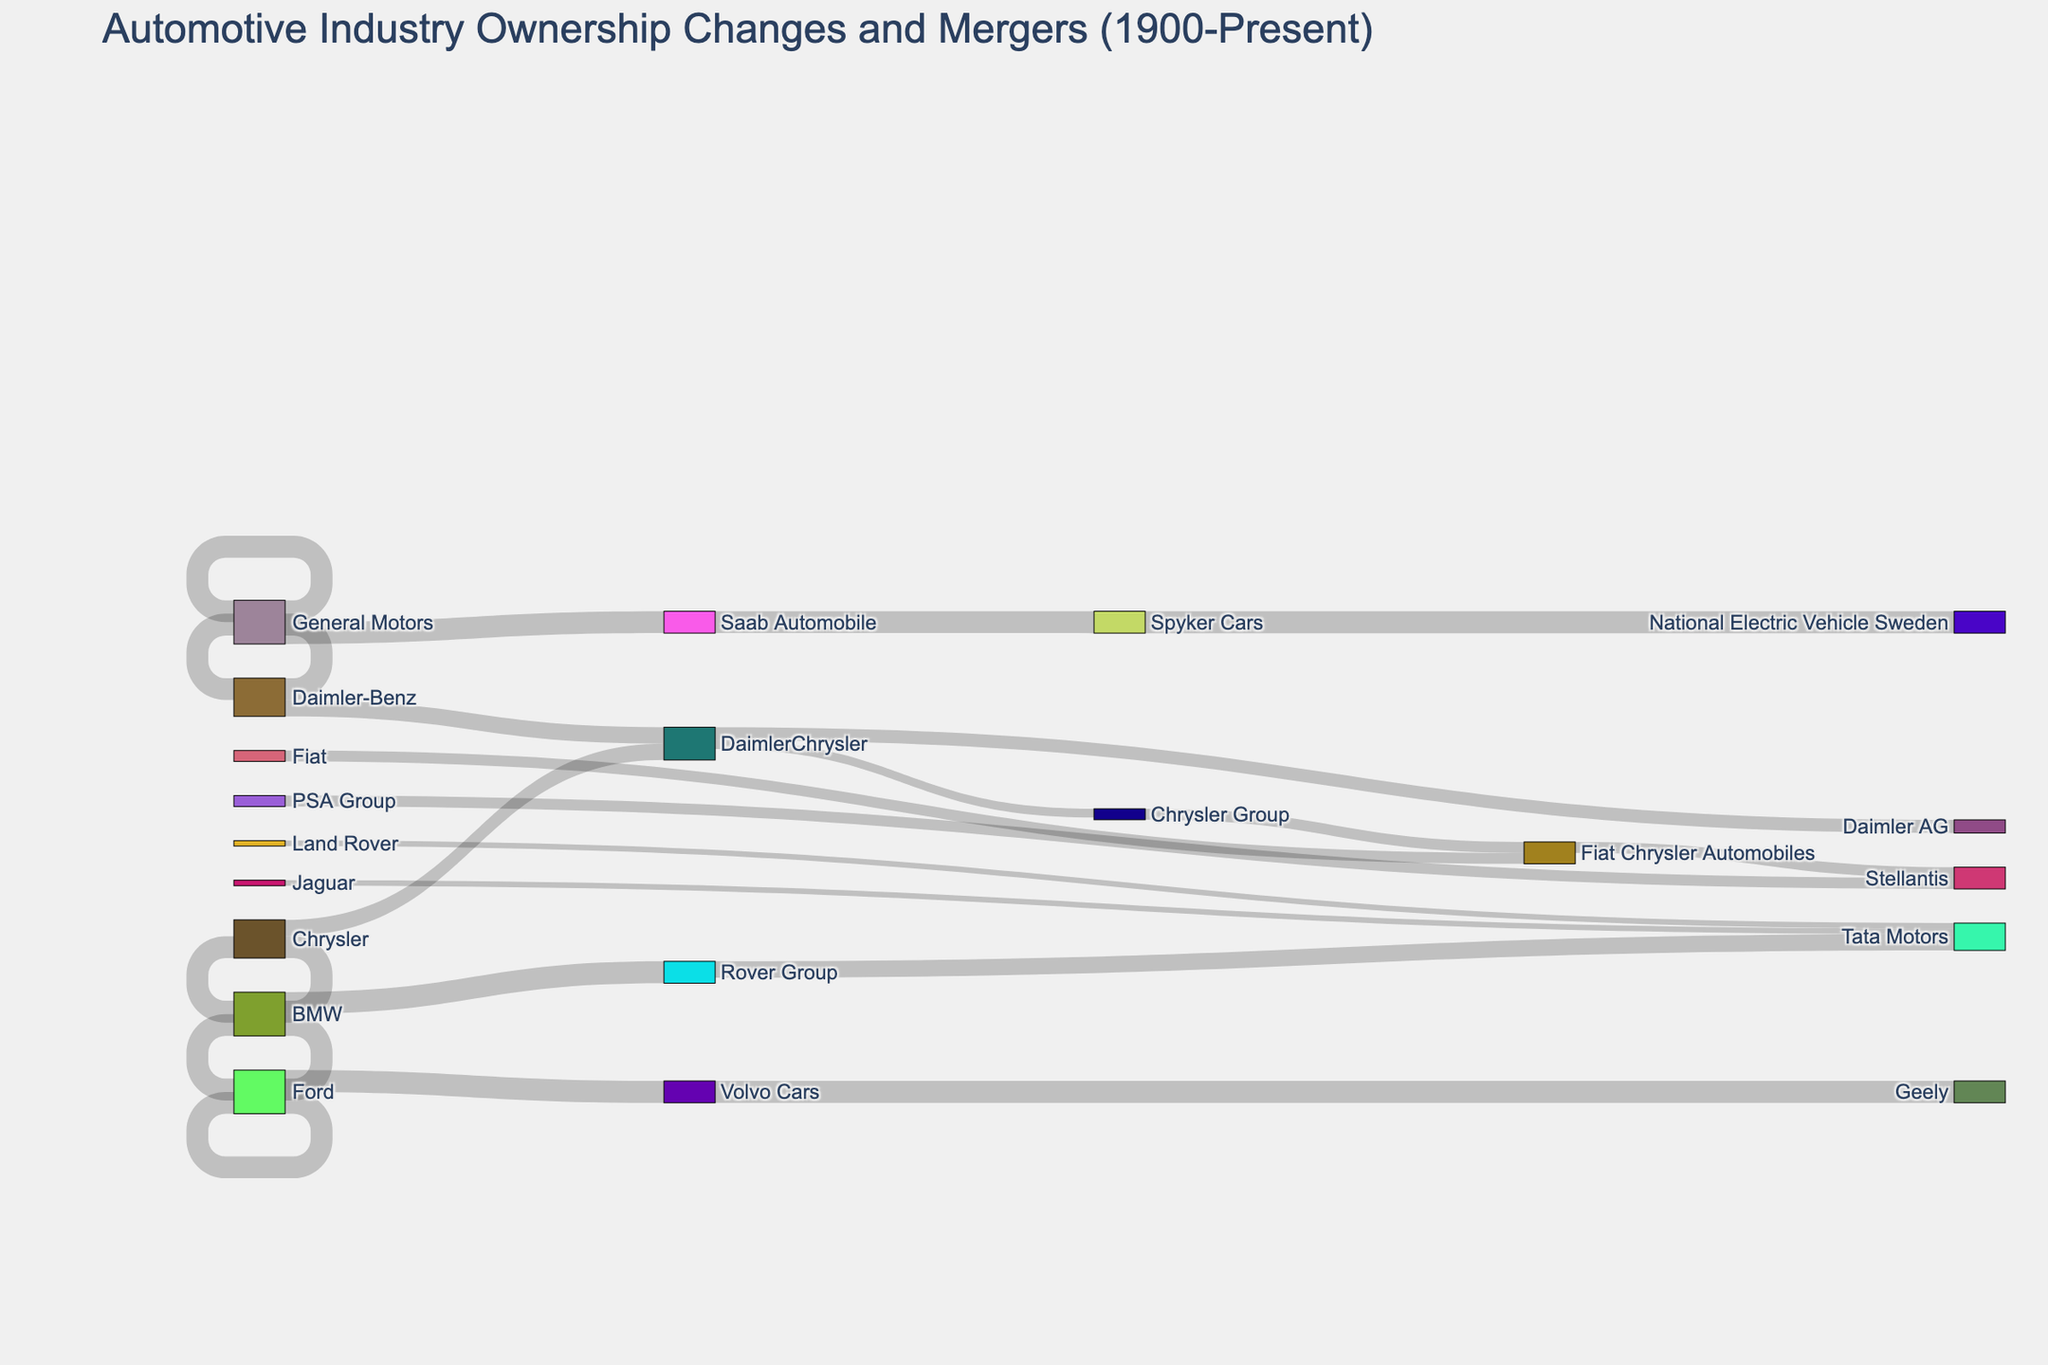How many companies does "Ford" directly transition to in the diagram? By examining the arrows originating from the "Ford" node, we see one arrow pointing towards "Volvo Cars." Consequently, Ford directly transitions to one other company.
Answer: One Which companies are involved in the merger that leads to the formation of DaimlerChrysler? The arrows in the diagram indicate a merger between "Chrysler" and "Daimler-Benz" to form "DaimlerChrysler." Both companies are sources of arrows converging into the "DaimlerChrysler" target node.
Answer: Chrysler and Daimler-Benz What happens to "Volvo Cars" according to the diagram? The diagram shows one arrow originating from "Volvo Cars" and leading to "Geely." This transition represents the ownership change of Volvo Cars to Geely.
Answer: Purchased by Geely What are the end states of "Fiat Chrysler Automobiles" in the diagram? According to the arrows, "Fiat Chrysler Automobiles" transitions to "Stellantis." Hence, the end state of Fiat Chrysler Automobiles leads to Stellantis.
Answer: Stellantis Which company transitions to Tata Motors besides the Rover Group? The diagram shows two arrows pointing towards Tata Motors, originating from "Rover Group" and "Jaguar." These indicate that both of these entities transitioned to Tata Motors.
Answer: Jaguar How many companies does "DaimlerChrysler" transition into, and what are they? Examining the arrows originating from "DaimlerChrysler," we see two arrows pointing towards "Daimler AG" and "Chrysler Group." Therefore, DaimlerChrysler transitions into two different companies.
Answer: Two; Daimler AG and Chrysler Group What change occurs to "Spyker Cars" according to the diagram? The diagram shows an arrow from "Spyker Cars" to "National Electric Vehicle Sweden." This indicates that Spyker Cars was acquired or transitioned into National Electric Vehicle Sweden.
Answer: Acquired by National Electric Vehicle Sweden What is the unique outcome for Saab Automobile in the diagram? By tracing the arrows, we see an arrow from "Saab Automobile" going to "Spyker Cars," signifying this unique transition. Since no other arrows stem from Saab Automobile elsewhere, this is its only transformation.
Answer: Acquired by Spyker Cars 